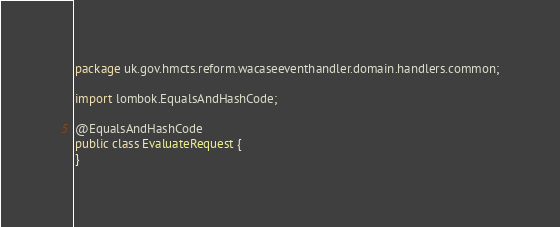<code> <loc_0><loc_0><loc_500><loc_500><_Java_>package uk.gov.hmcts.reform.wacaseeventhandler.domain.handlers.common;

import lombok.EqualsAndHashCode;

@EqualsAndHashCode
public class EvaluateRequest {
}
</code> 